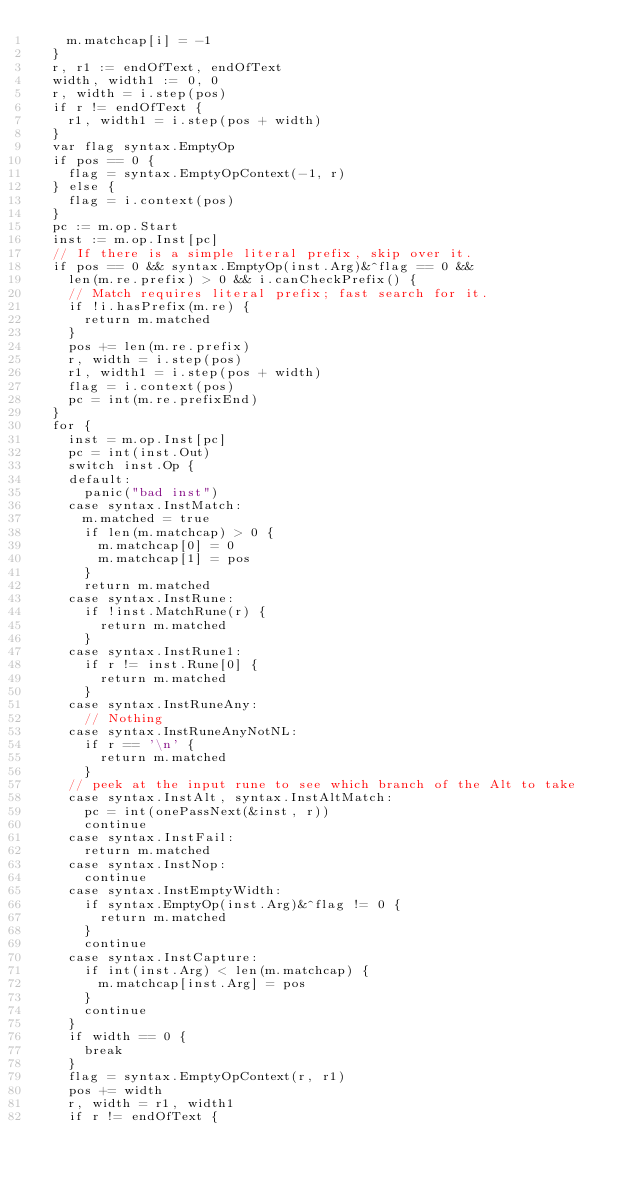Convert code to text. <code><loc_0><loc_0><loc_500><loc_500><_Go_>		m.matchcap[i] = -1
	}
	r, r1 := endOfText, endOfText
	width, width1 := 0, 0
	r, width = i.step(pos)
	if r != endOfText {
		r1, width1 = i.step(pos + width)
	}
	var flag syntax.EmptyOp
	if pos == 0 {
		flag = syntax.EmptyOpContext(-1, r)
	} else {
		flag = i.context(pos)
	}
	pc := m.op.Start
	inst := m.op.Inst[pc]
	// If there is a simple literal prefix, skip over it.
	if pos == 0 && syntax.EmptyOp(inst.Arg)&^flag == 0 &&
		len(m.re.prefix) > 0 && i.canCheckPrefix() {
		// Match requires literal prefix; fast search for it.
		if !i.hasPrefix(m.re) {
			return m.matched
		}
		pos += len(m.re.prefix)
		r, width = i.step(pos)
		r1, width1 = i.step(pos + width)
		flag = i.context(pos)
		pc = int(m.re.prefixEnd)
	}
	for {
		inst = m.op.Inst[pc]
		pc = int(inst.Out)
		switch inst.Op {
		default:
			panic("bad inst")
		case syntax.InstMatch:
			m.matched = true
			if len(m.matchcap) > 0 {
				m.matchcap[0] = 0
				m.matchcap[1] = pos
			}
			return m.matched
		case syntax.InstRune:
			if !inst.MatchRune(r) {
				return m.matched
			}
		case syntax.InstRune1:
			if r != inst.Rune[0] {
				return m.matched
			}
		case syntax.InstRuneAny:
			// Nothing
		case syntax.InstRuneAnyNotNL:
			if r == '\n' {
				return m.matched
			}
		// peek at the input rune to see which branch of the Alt to take
		case syntax.InstAlt, syntax.InstAltMatch:
			pc = int(onePassNext(&inst, r))
			continue
		case syntax.InstFail:
			return m.matched
		case syntax.InstNop:
			continue
		case syntax.InstEmptyWidth:
			if syntax.EmptyOp(inst.Arg)&^flag != 0 {
				return m.matched
			}
			continue
		case syntax.InstCapture:
			if int(inst.Arg) < len(m.matchcap) {
				m.matchcap[inst.Arg] = pos
			}
			continue
		}
		if width == 0 {
			break
		}
		flag = syntax.EmptyOpContext(r, r1)
		pos += width
		r, width = r1, width1
		if r != endOfText {</code> 